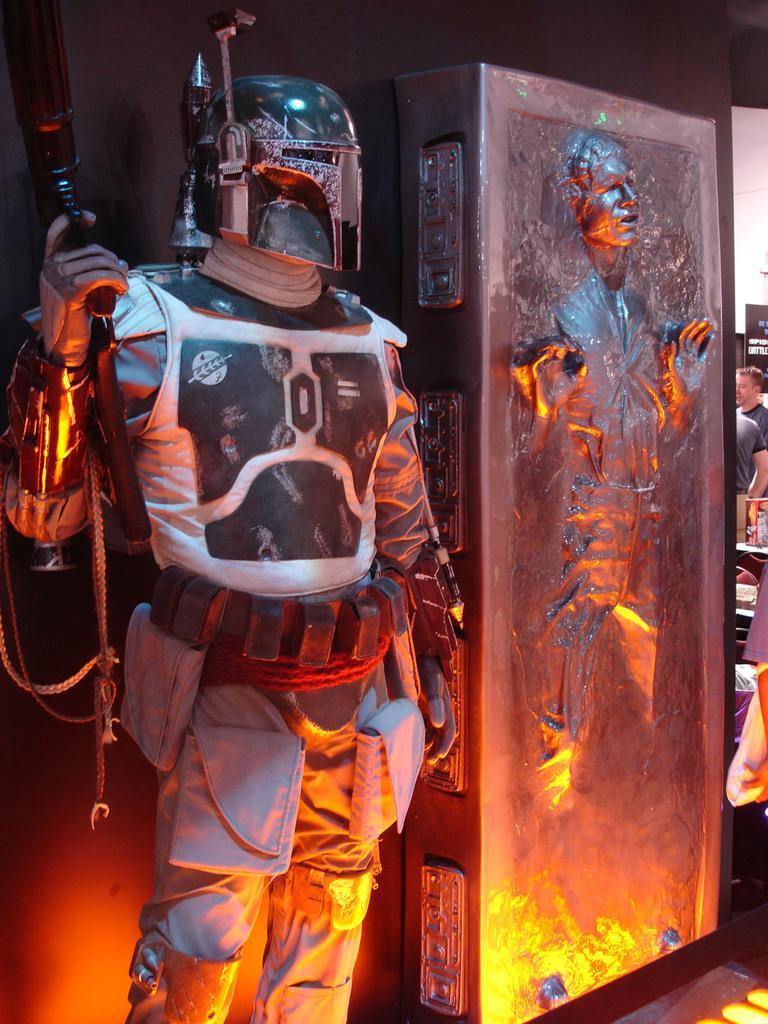In one or two sentences, can you explain what this image depicts? In this picture we can see few people, in the left side of the image we can see a man, he wore a suit, and he is holding a gun, in the background we can see a hoarding. 